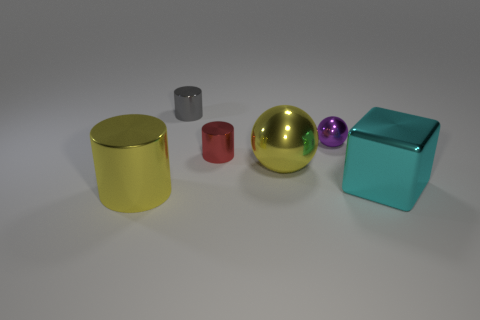Does the shiny object in front of the large cyan object have the same color as the metal ball that is left of the tiny sphere?
Provide a short and direct response. Yes. There is a big yellow thing that is to the right of the red object; does it have the same shape as the purple metallic object that is behind the large cyan metallic cube?
Give a very brief answer. Yes. There is a yellow sphere that is the same size as the cyan thing; what is its material?
Give a very brief answer. Metal. How many other objects are the same material as the large yellow sphere?
Keep it short and to the point. 5. Do the big shiny ball and the large metallic cylinder have the same color?
Make the answer very short. Yes. What number of large things are balls or cyan metallic things?
Your response must be concise. 2. The large metal object that is left of the cyan cube and to the right of the gray shiny cylinder is what color?
Keep it short and to the point. Yellow. Is the large yellow cylinder made of the same material as the small purple object?
Ensure brevity in your answer.  Yes. There is a small gray object; what shape is it?
Give a very brief answer. Cylinder. There is a yellow object that is right of the shiny cylinder in front of the cyan object; what number of gray cylinders are in front of it?
Your response must be concise. 0. 